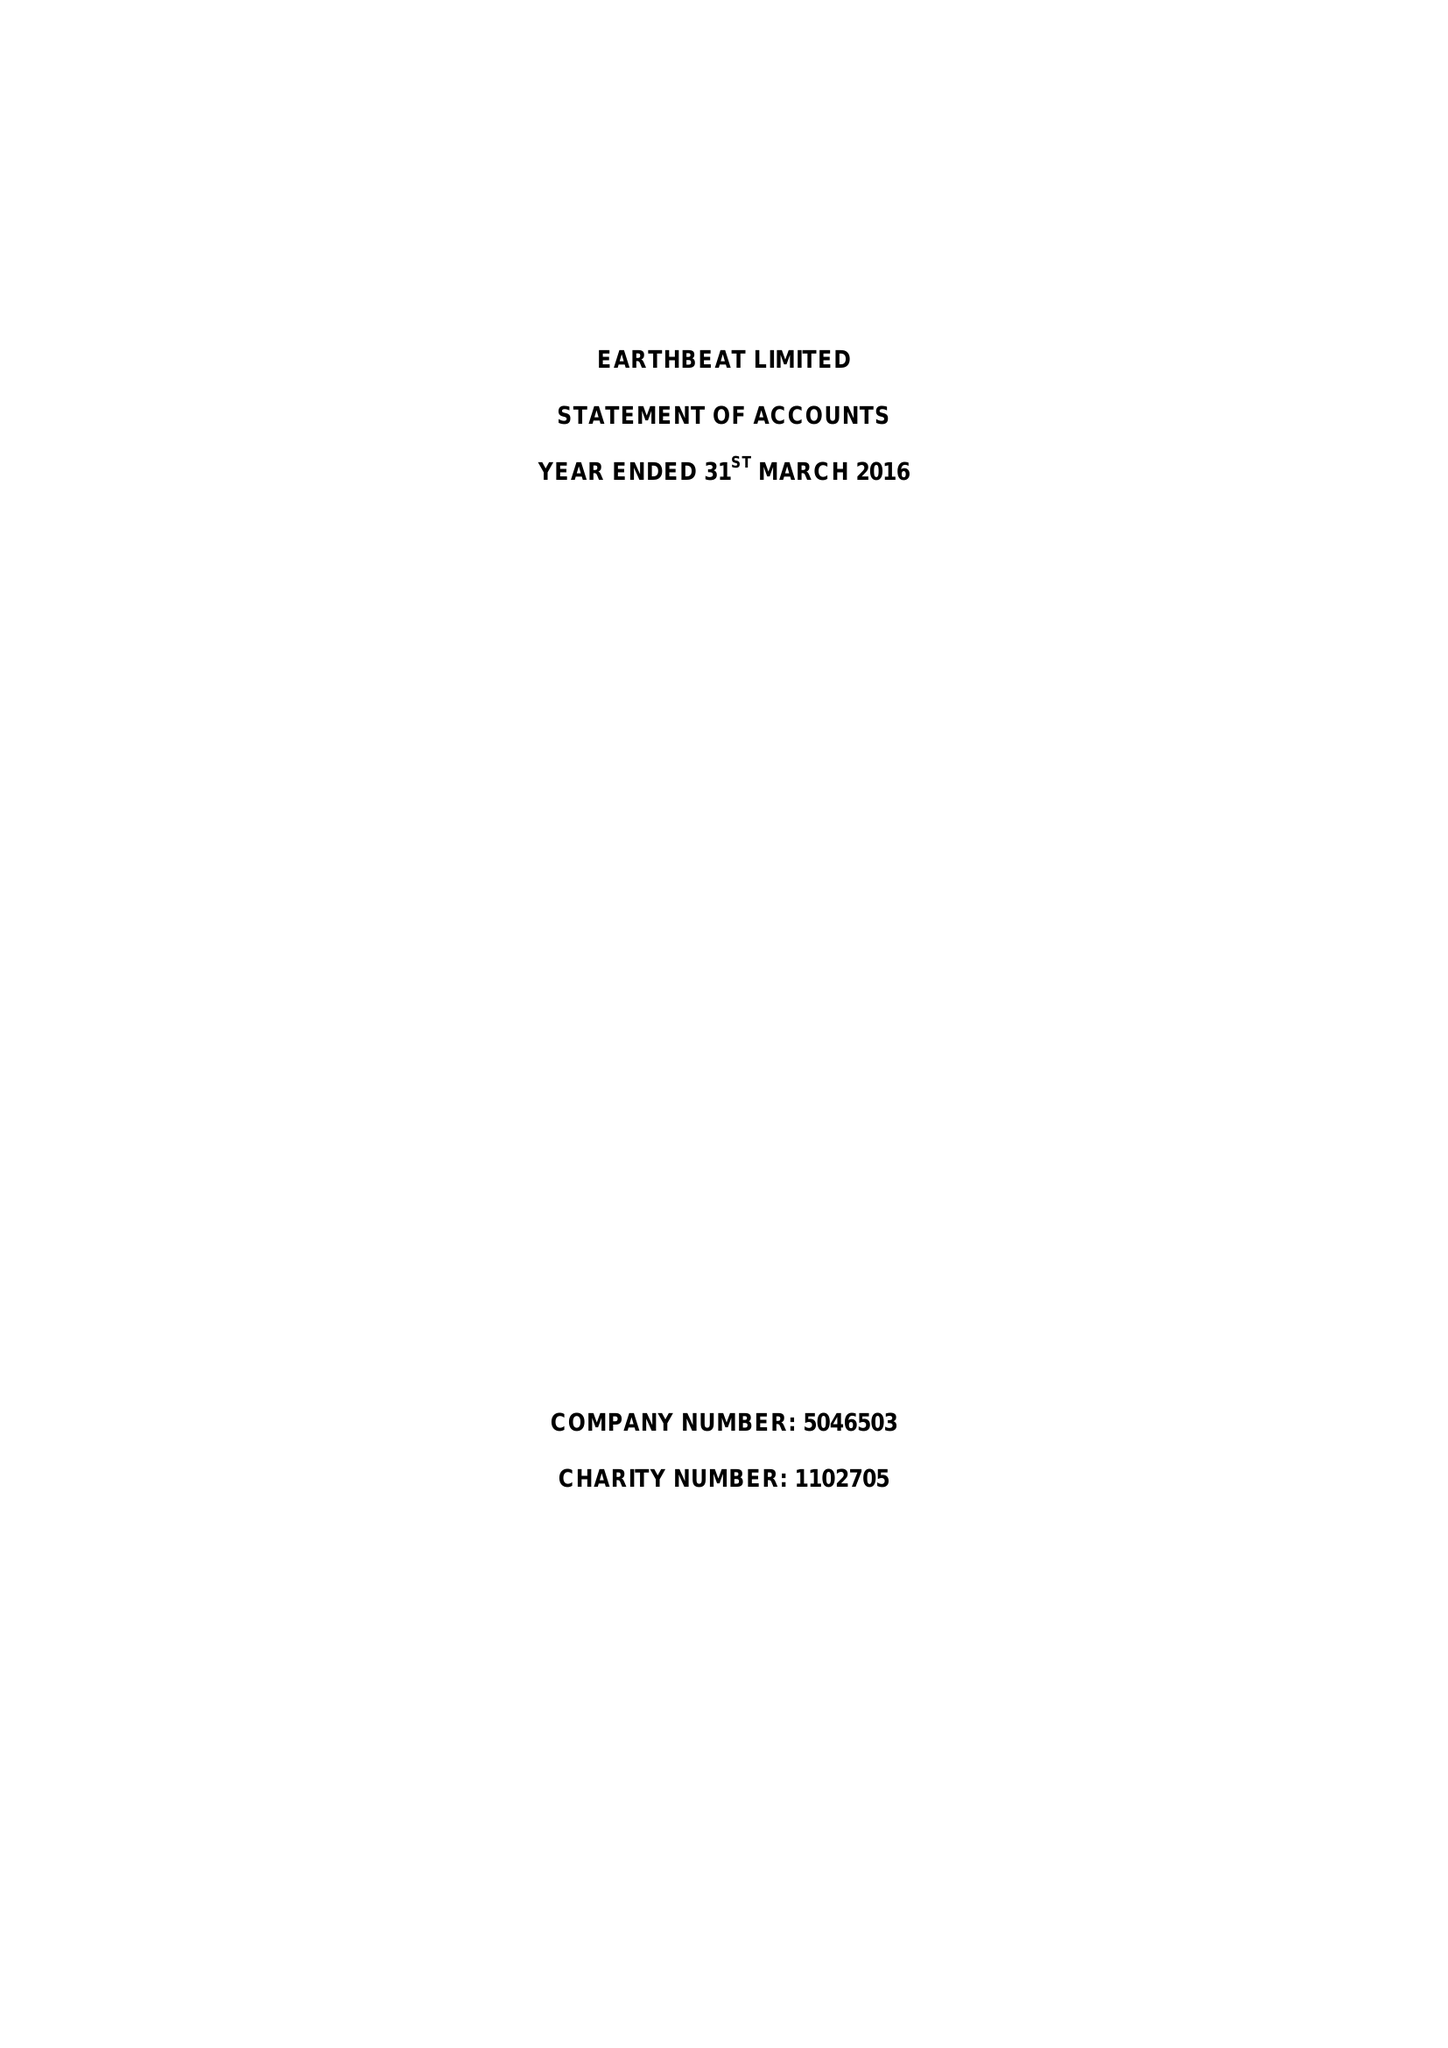What is the value for the address__street_line?
Answer the question using a single word or phrase. 68 THE HEADLANDS 